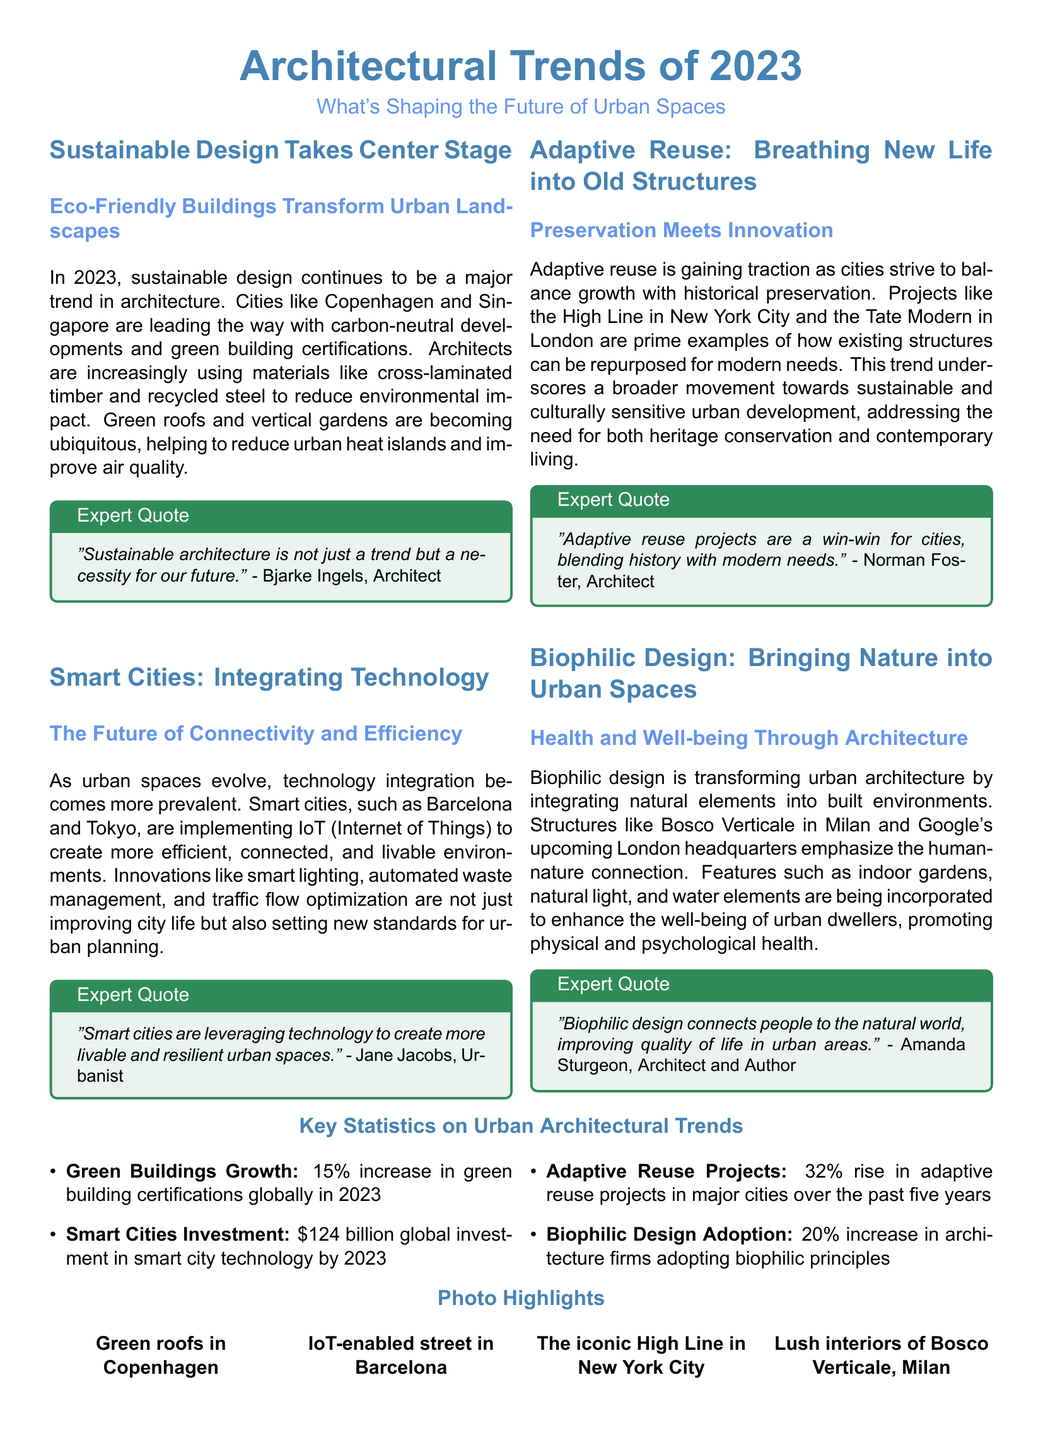What is one of the major trends in architecture for 2023? The document states that sustainable design is a major trend in architecture for 2023.
Answer: Sustainable design Which cities are mentioned as leaders in eco-friendly buildings? The cities mentioned are Copenhagen and Singapore as leaders in eco-friendly buildings.
Answer: Copenhagen and Singapore How much was the global investment in smart city technology by 2023? The document indicates that the global investment in smart city technology by 2023 is $124 billion.
Answer: $124 billion What percentage increase in green building certifications is noted for 2023? The document reports a 15% increase in green building certifications globally in 2023.
Answer: 15% Who is quoted regarding smart cities creating more livable spaces? Jane Jacobs is the expert quoted regarding smart cities.
Answer: Jane Jacobs What is a key benefit of biophilic design mentioned in the article? The document highlights that biophilic design improves quality of life in urban areas.
Answer: Improves quality of life Which architectural trend is associated with the preservation of historical structures? The trend associated with preservation is adaptive reuse.
Answer: Adaptive reuse What type of design emphasizes the integration of natural elements? The type of design that emphasizes natural elements is biophilic design.
Answer: Biophilic design 